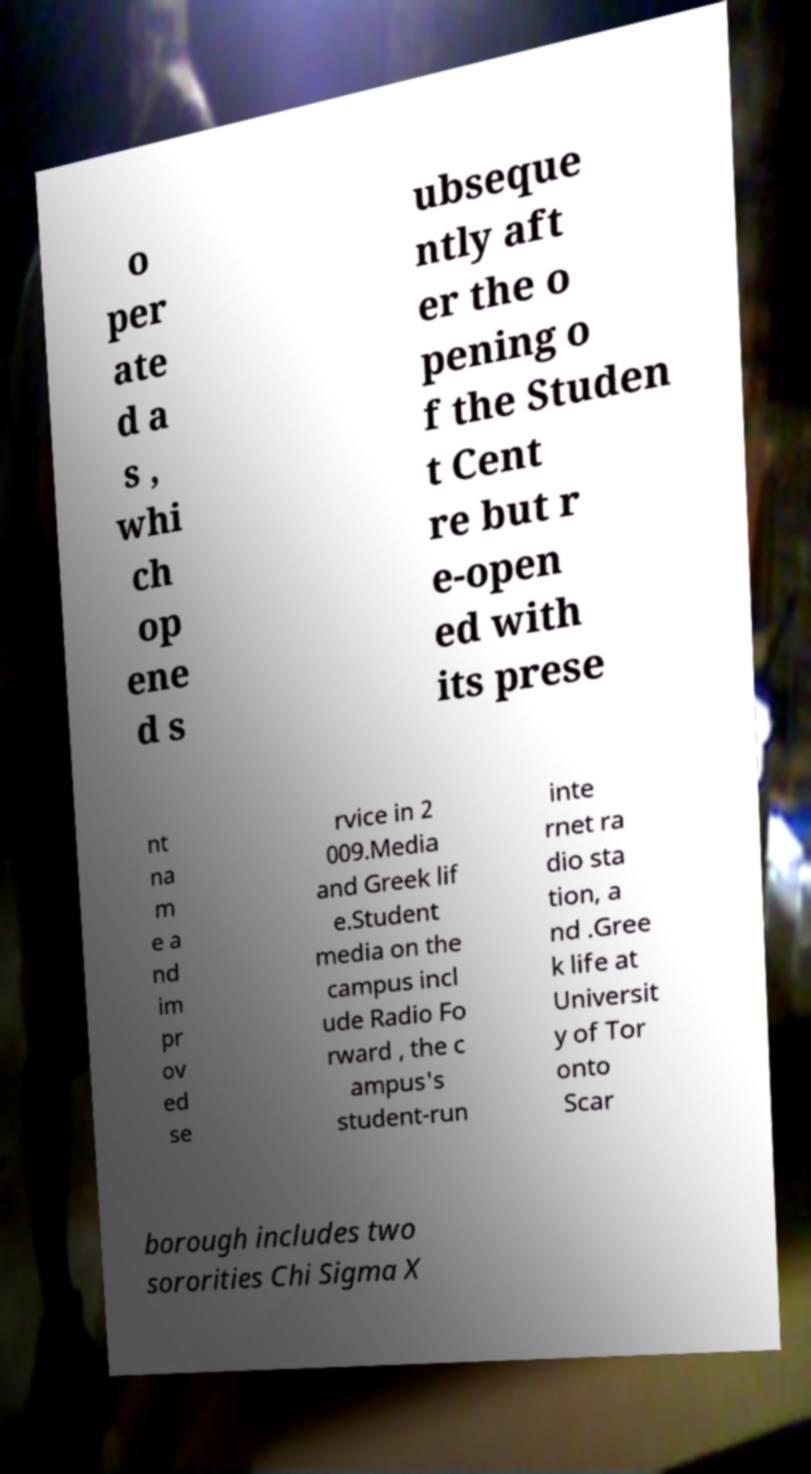Could you assist in decoding the text presented in this image and type it out clearly? o per ate d a s , whi ch op ene d s ubseque ntly aft er the o pening o f the Studen t Cent re but r e-open ed with its prese nt na m e a nd im pr ov ed se rvice in 2 009.Media and Greek lif e.Student media on the campus incl ude Radio Fo rward , the c ampus's student-run inte rnet ra dio sta tion, a nd .Gree k life at Universit y of Tor onto Scar borough includes two sororities Chi Sigma X 